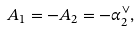Convert formula to latex. <formula><loc_0><loc_0><loc_500><loc_500>A _ { 1 } = - A _ { 2 } = - \alpha ^ { \vee } _ { 2 } ,</formula> 